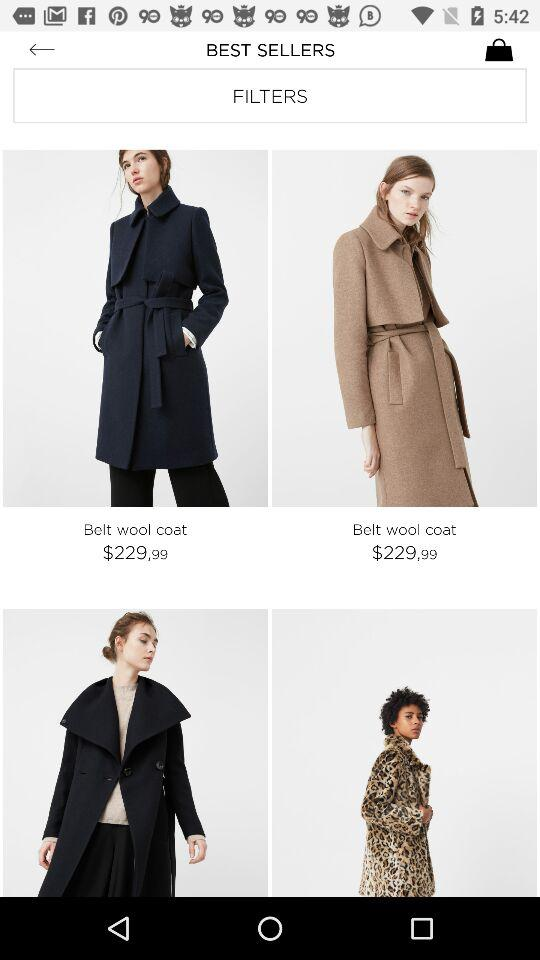What is the cost of the Belt wool coat? The cost is $229,99. 